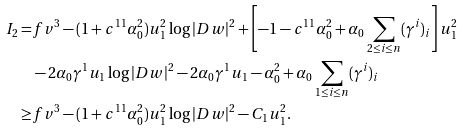Convert formula to latex. <formula><loc_0><loc_0><loc_500><loc_500>I _ { 2 } = & f v ^ { 3 } - ( 1 + c ^ { 1 1 } \alpha _ { 0 } ^ { 2 } ) u _ { 1 } ^ { 2 } \log | D w | ^ { 2 } + \left [ - 1 - c ^ { 1 1 } \alpha _ { 0 } ^ { 2 } + \alpha _ { 0 } \sum _ { 2 \leq i \leq n } ( \gamma ^ { i } ) _ { i } \right ] u _ { 1 } ^ { 2 } \\ & - 2 \alpha _ { 0 } \gamma ^ { 1 } u _ { 1 } \log | D w | ^ { 2 } - 2 \alpha _ { 0 } \gamma ^ { 1 } u _ { 1 } - \alpha _ { 0 } ^ { 2 } + \alpha _ { 0 } \sum _ { 1 \leq i \leq n } ( \gamma ^ { i } ) _ { i } \\ \geq & f v ^ { 3 } - ( 1 + c ^ { 1 1 } \alpha _ { 0 } ^ { 2 } ) u _ { 1 } ^ { 2 } \log | D w | ^ { 2 } - C _ { 1 } u _ { 1 } ^ { 2 } .</formula> 